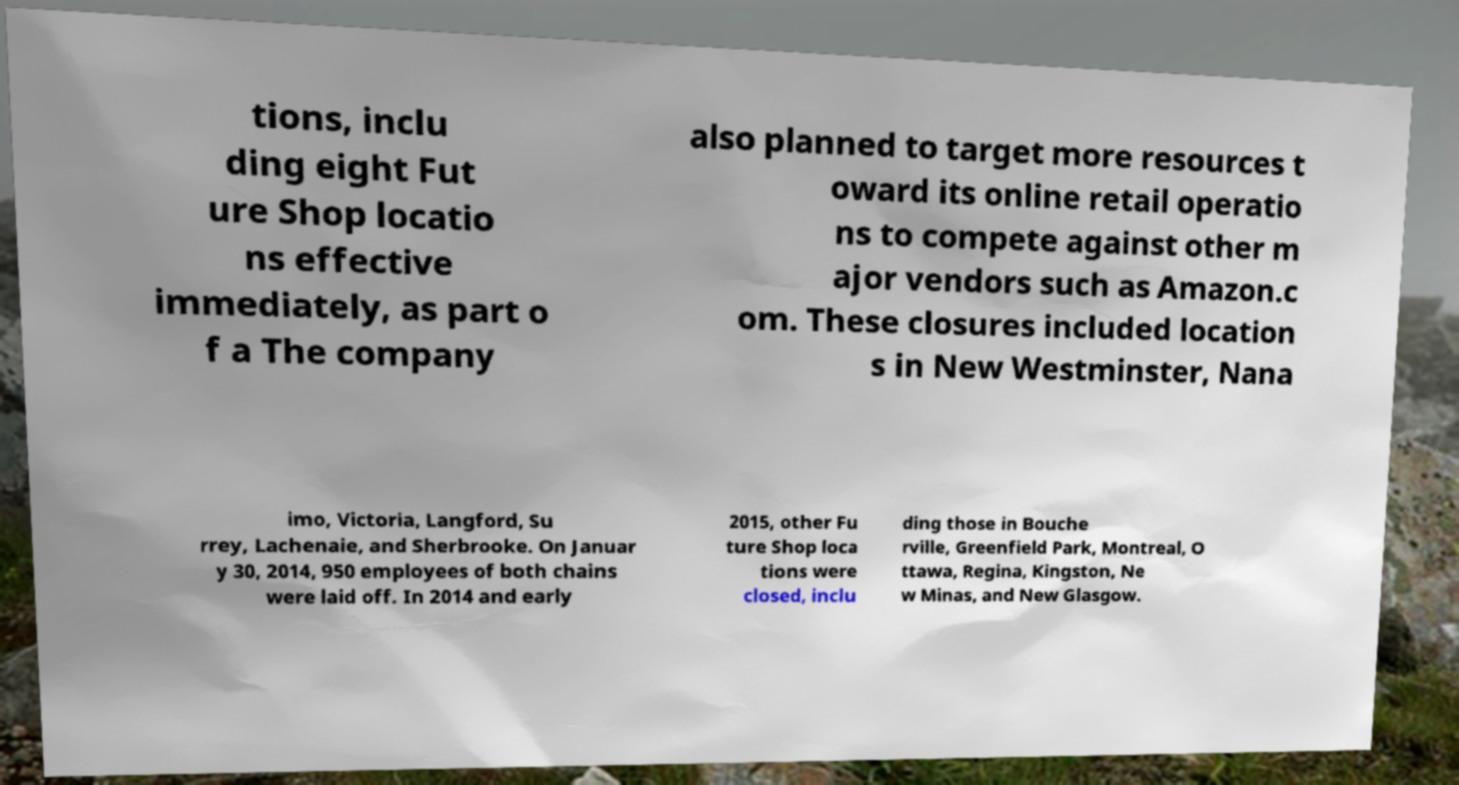For documentation purposes, I need the text within this image transcribed. Could you provide that? tions, inclu ding eight Fut ure Shop locatio ns effective immediately, as part o f a The company also planned to target more resources t oward its online retail operatio ns to compete against other m ajor vendors such as Amazon.c om. These closures included location s in New Westminster, Nana imo, Victoria, Langford, Su rrey, Lachenaie, and Sherbrooke. On Januar y 30, 2014, 950 employees of both chains were laid off. In 2014 and early 2015, other Fu ture Shop loca tions were closed, inclu ding those in Bouche rville, Greenfield Park, Montreal, O ttawa, Regina, Kingston, Ne w Minas, and New Glasgow. 